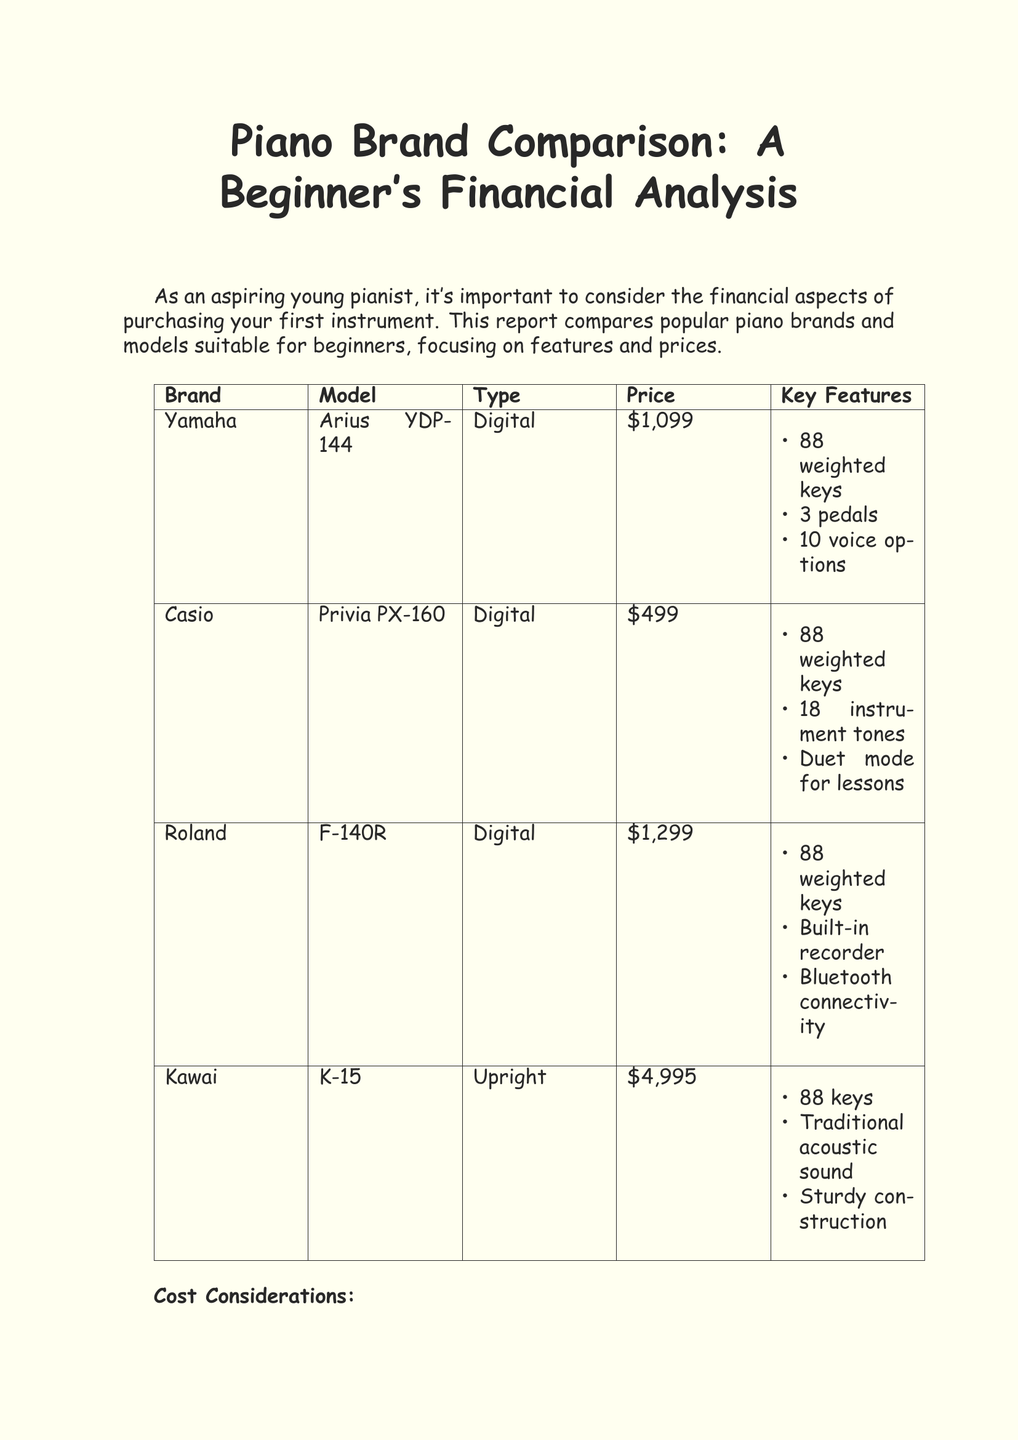What is the price of the Yamaha Arius YDP-144? The price of the Yamaha Arius YDP-144 is listed in the document as $1,099.
Answer: $1,099 What brand offers Bluetooth connectivity? The document states that the Roland F-140R includes Bluetooth connectivity as a key feature.
Answer: Roland How many key features does the Casio Privia PX-160 have? The document lists three key features for the Casio Privia PX-160: 88 weighted keys, 18 instrument tones, and Duet mode for lessons.
Answer: 3 What is the type of the Kawai K-15 piano? The document categorizes the Kawai K-15 as an upright piano.
Answer: Upright What is one cost consideration mentioned in the document? The document outlines several cost considerations, such as delivery and setup fees, which are necessary when buying a piano.
Answer: Delivery and setup fees Which piano model has the highest price? The document indicates that the Kawai K-15 has the highest price among the options listed.
Answer: Kawai K-15 What feature is unique to the Roland F-140R compared to others? The document highlights that the Roland F-140R has a built-in recorder, which is a unique feature compared to other models listed.
Answer: Built-in recorder Which piano is the most affordable option listed? The document specifies that the Casio Privia PX-160 is the most affordable choice at $499.
Answer: $499 What type of pianos does the report primarily focus on? The document concentrates on digital pianos and upright acoustic pianos as suitable options for beginners.
Answer: Digital and upright acoustic pianos 